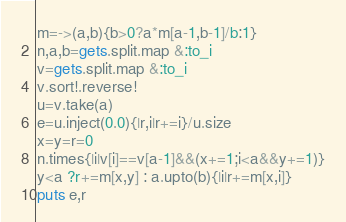Convert code to text. <code><loc_0><loc_0><loc_500><loc_500><_Ruby_>m=->(a,b){b>0?a*m[a-1,b-1]/b:1}
n,a,b=gets.split.map &:to_i
v=gets.split.map &:to_i
v.sort!.reverse!
u=v.take(a)
e=u.inject(0.0){|r,i|r+=i}/u.size
x=y=r=0
n.times{|i|v[i]==v[a-1]&&(x+=1;i<a&&y+=1)}
y<a ?r+=m[x,y] : a.upto(b){|i|r+=m[x,i]}
puts e,r</code> 